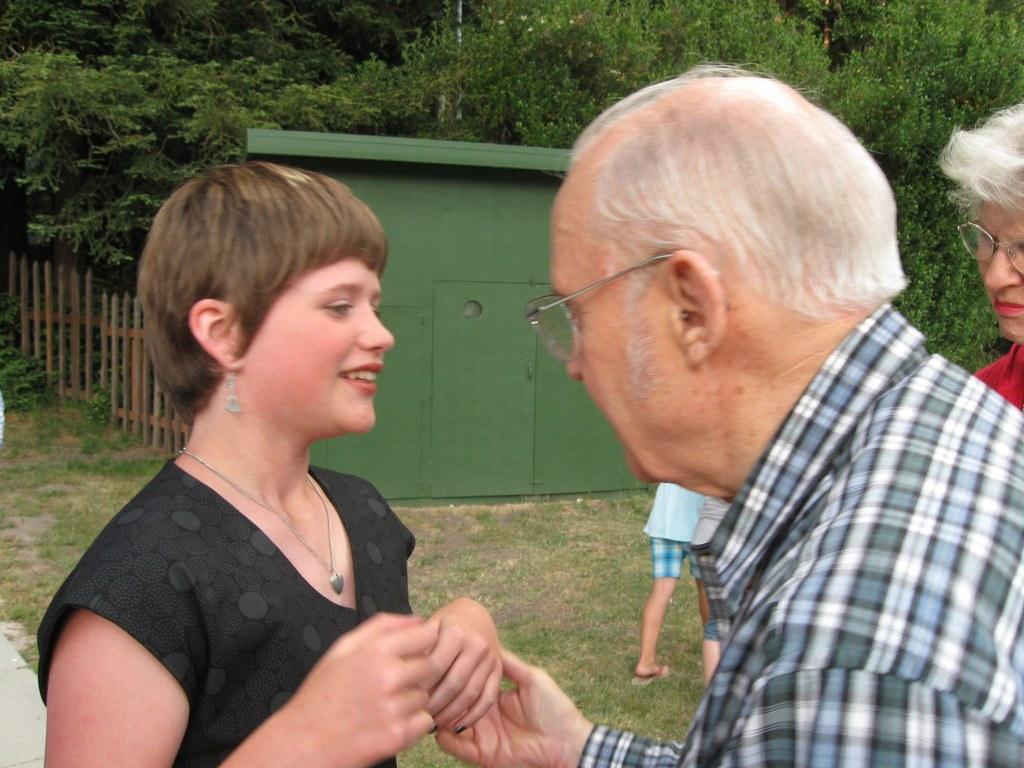Could you give a brief overview of what you see in this image? In this image, we can see people and some are wearing glasses. In the background, there are trees and we can see a shed and a fence. 